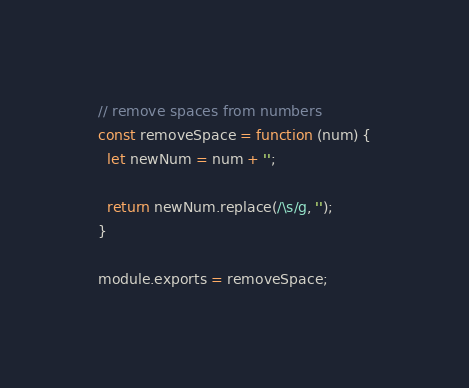Convert code to text. <code><loc_0><loc_0><loc_500><loc_500><_JavaScript_>// remove spaces from numbers
const removeSpace = function (num) {
  let newNum = num + '';

  return newNum.replace(/\s/g, '');
}

module.exports = removeSpace;</code> 